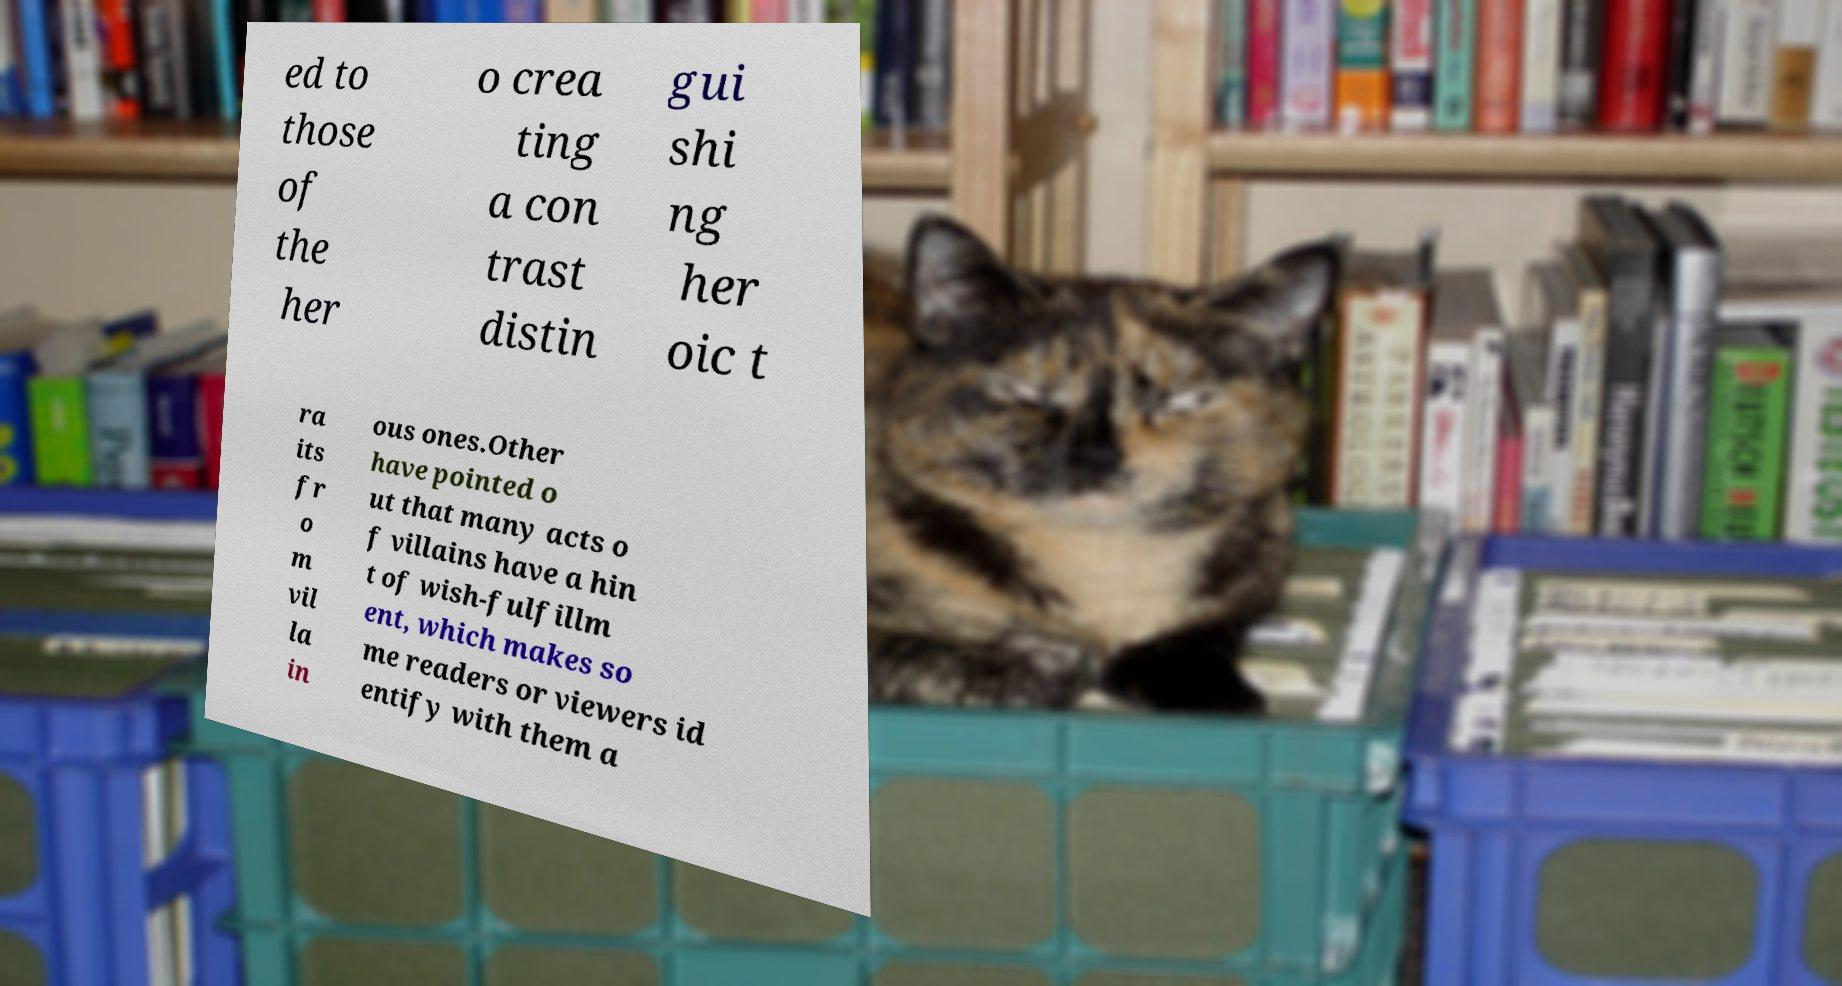Can you accurately transcribe the text from the provided image for me? ed to those of the her o crea ting a con trast distin gui shi ng her oic t ra its fr o m vil la in ous ones.Other have pointed o ut that many acts o f villains have a hin t of wish-fulfillm ent, which makes so me readers or viewers id entify with them a 